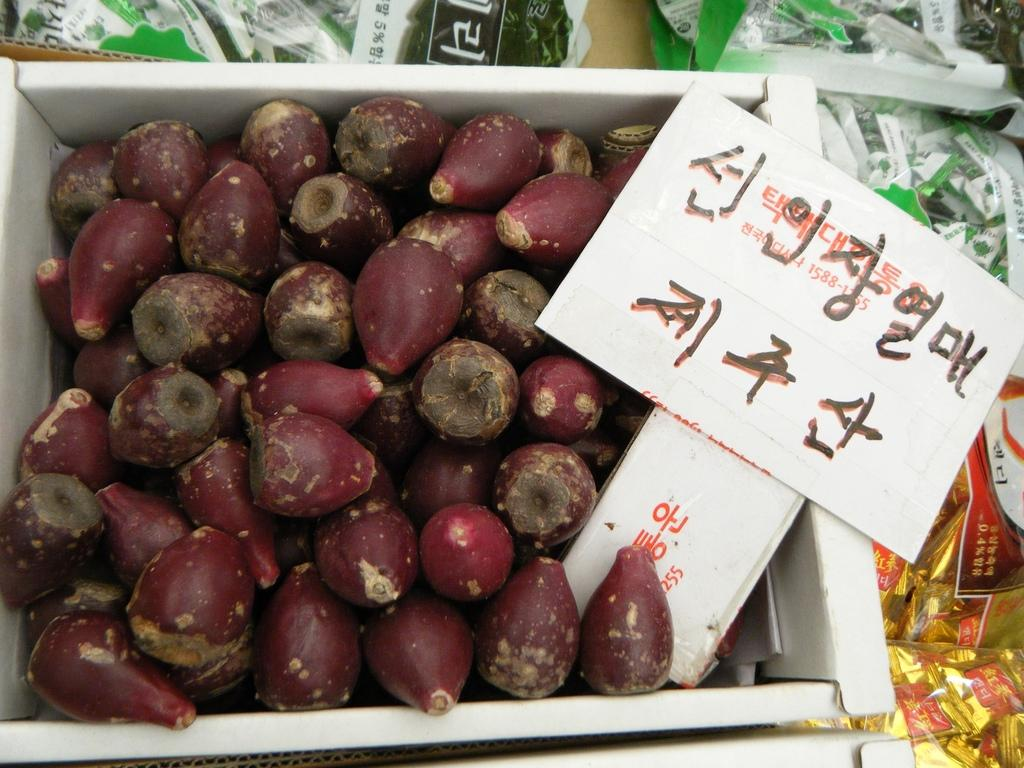What type of food items are present in the image? There are vegetables in the image. How are the vegetables arranged or contained in the image? The vegetables are in a box. What additional object can be seen in the image? There is a name board in the image. What information is displayed on the name board? There is text on the name board. What type of invention is being demonstrated by the dog in the image? There is no dog present in the image, and therefore no invention being demonstrated. 